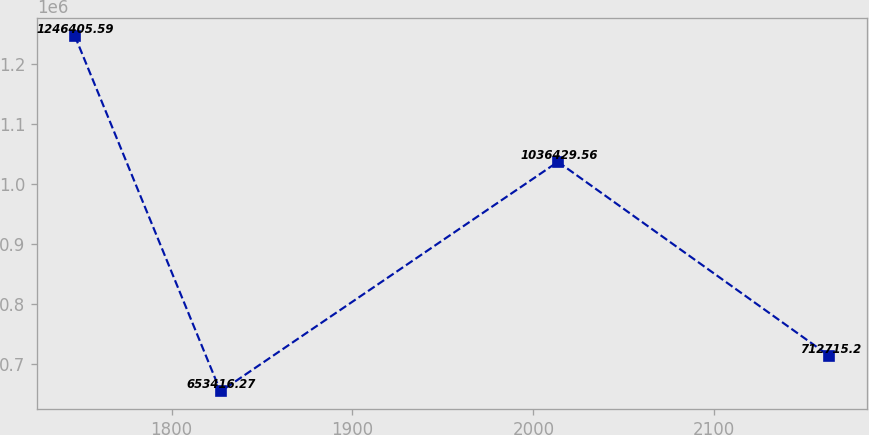Convert chart to OTSL. <chart><loc_0><loc_0><loc_500><loc_500><line_chart><ecel><fcel>Unnamed: 1<nl><fcel>1746.56<fcel>1.24641e+06<nl><fcel>1827.1<fcel>653416<nl><fcel>2013.56<fcel>1.03643e+06<nl><fcel>2163.56<fcel>712715<nl></chart> 